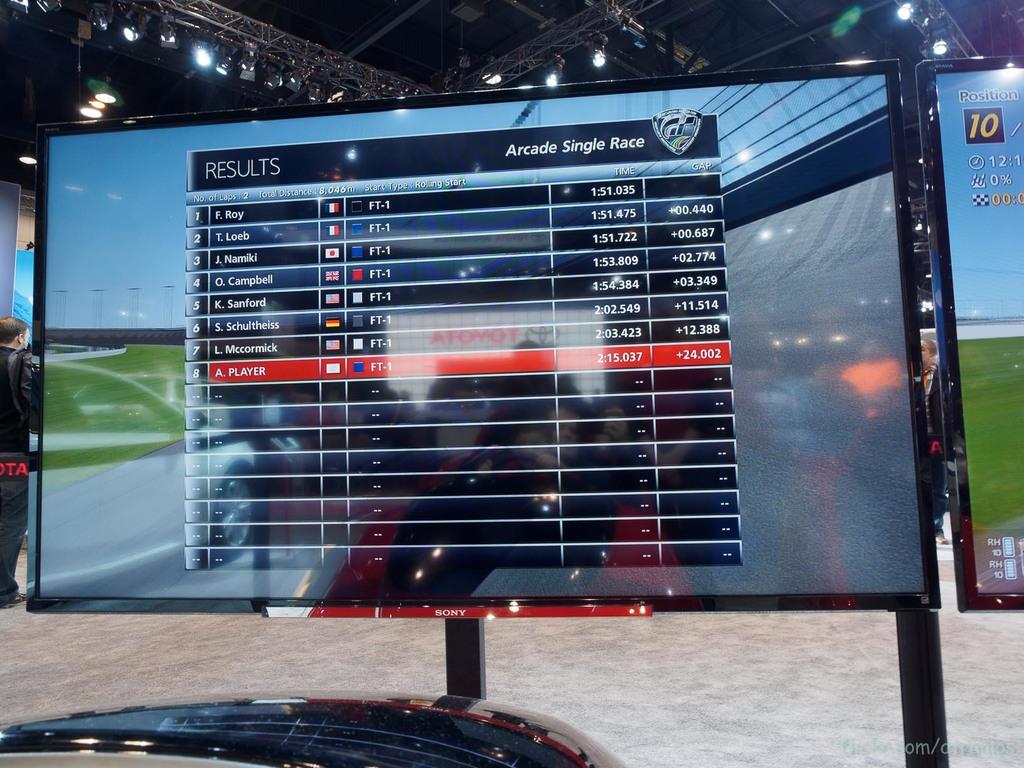What is displayed here?
Offer a very short reply. Results. 